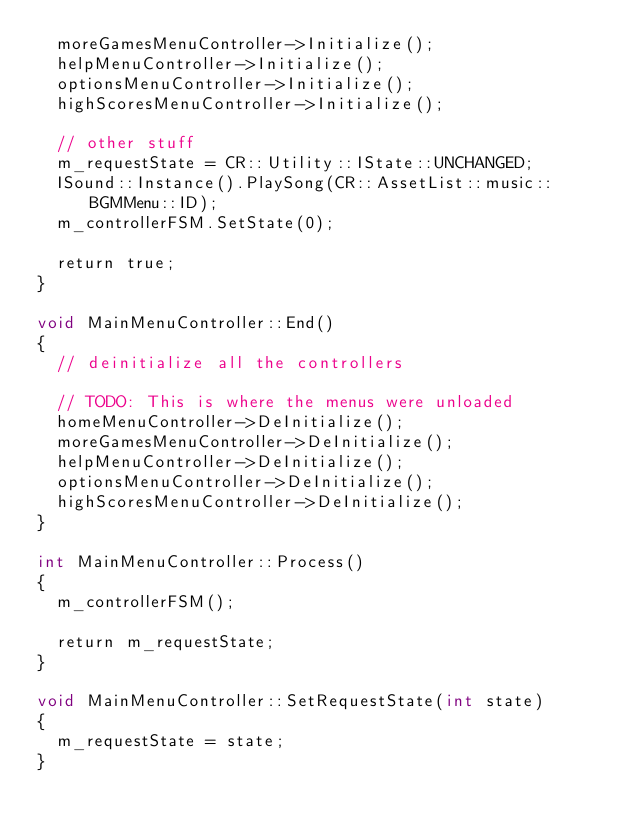Convert code to text. <code><loc_0><loc_0><loc_500><loc_500><_ObjectiveC_>	moreGamesMenuController->Initialize();
	helpMenuController->Initialize();
	optionsMenuController->Initialize();
	highScoresMenuController->Initialize();
	
	// other stuff
	m_requestState = CR::Utility::IState::UNCHANGED;
	ISound::Instance().PlaySong(CR::AssetList::music::BGMMenu::ID);
	m_controllerFSM.SetState(0);
	
	return true;
}

void MainMenuController::End()
{
	// deinitialize all the controllers
	
	// TODO: This is where the menus were unloaded
	homeMenuController->DeInitialize();
	moreGamesMenuController->DeInitialize();
	helpMenuController->DeInitialize();
	optionsMenuController->DeInitialize();
	highScoresMenuController->DeInitialize();
}

int MainMenuController::Process()
{
	m_controllerFSM();
	
	return m_requestState;
}

void MainMenuController::SetRequestState(int state)
{
	m_requestState = state;
}</code> 